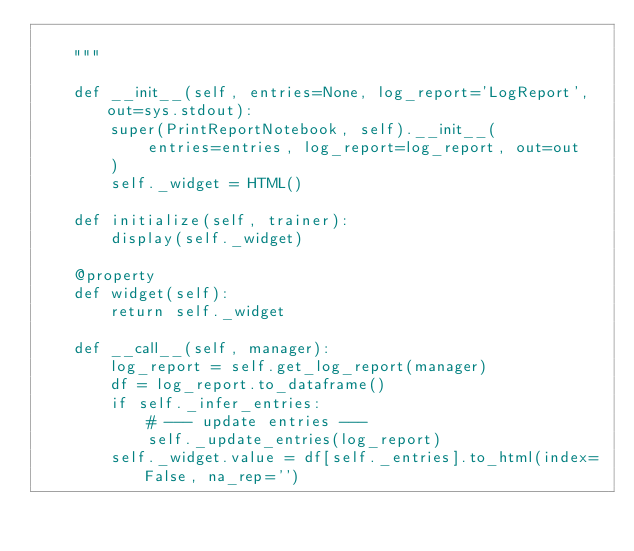Convert code to text. <code><loc_0><loc_0><loc_500><loc_500><_Python_>
    """

    def __init__(self, entries=None, log_report='LogReport', out=sys.stdout):
        super(PrintReportNotebook, self).__init__(
            entries=entries, log_report=log_report, out=out
        )
        self._widget = HTML()

    def initialize(self, trainer):
        display(self._widget)

    @property
    def widget(self):
        return self._widget

    def __call__(self, manager):
        log_report = self.get_log_report(manager)
        df = log_report.to_dataframe()
        if self._infer_entries:
            # --- update entries ---
            self._update_entries(log_report)
        self._widget.value = df[self._entries].to_html(index=False, na_rep='')
</code> 